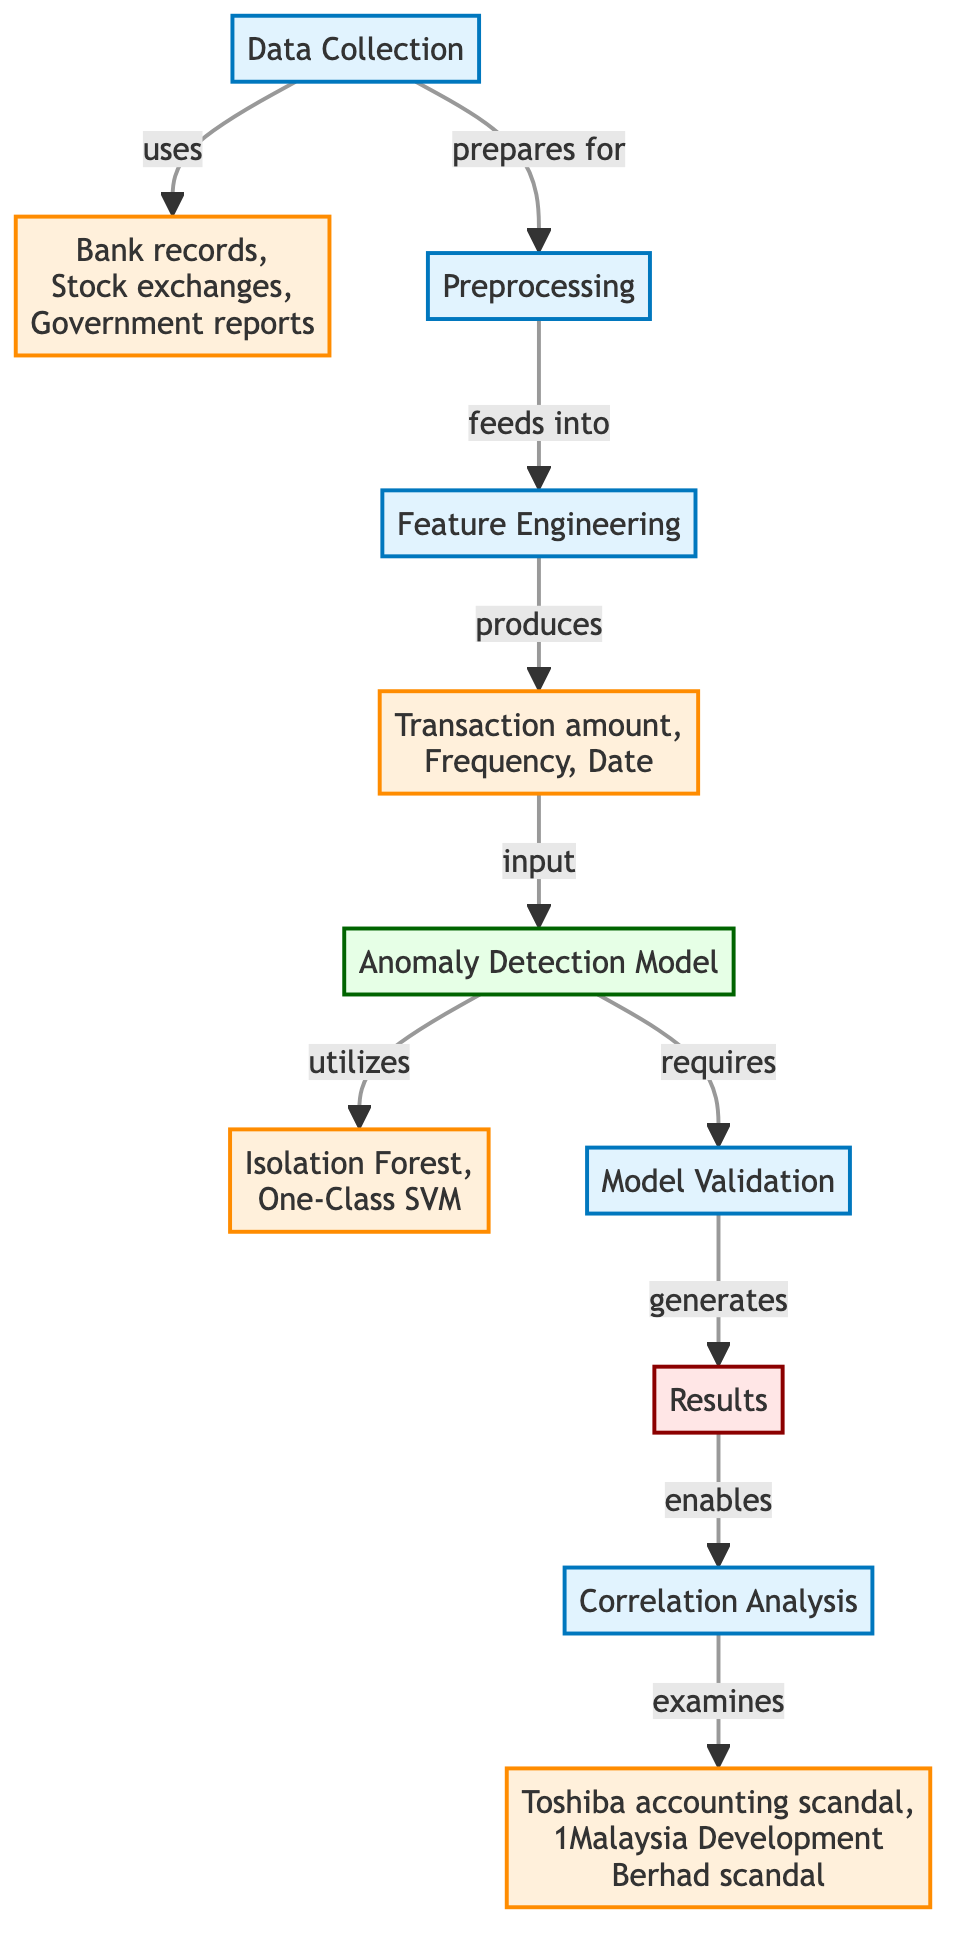What are the data sources listed in the diagram? The diagram explicitly names the data sources as "Bank records," "Stock exchanges," and "Government reports." These elements are located within the "Data Sources" node, directly associated with the "Data Collection" process.
Answer: Bank records, Stock exchanges, Government reports How many algorithms are utilized in the anomaly detection model? The diagram indicates that there are two algorithms listed within the "Algorithms" node: "Isolation Forest" and "One-Class SVM." Since these are explicitly mentioned, we count them to determine the total.
Answer: 2 What is the output of the model validation step? From the diagram, the "Model Validation" step feeds into the "Results" node. Therefore, the output of "Model Validation" is what is generated in the "Results" node, making the correlation clear.
Answer: Results What features are produced after feature engineering? The diagram shows that the feature engineering step produces features such as "Transaction amount," "Frequency," and "Date." These are directly related to the "Features" node in the flowchart.
Answer: Transaction amount, Frequency, Date Which historical case studies are examined during the correlation analysis? The "Correlation Analysis" node leads to an examination of specific historical case studies, namely the "Toshiba accounting scandal" and the "1Malaysia Development Berhad scandal," which are clearly defined in the diagram.
Answer: Toshiba accounting scandal, 1Malaysia Development Berhad scandal What is the purpose of the preprocessing step? The "Preprocessing" step is characterized in the diagram as a process that prepares data for the next stage, which is "Feature Engineering." It serves to organize and clean the collected data before extracting features.
Answer: Prepares for Feature Engineering What type of model is being utilized for anomaly detection in the diagram? The diagram specifies that an "Anomaly Detection Model" is being utilized in the process. This model is central to understanding the mechanism through which anomalies are detected in financial transactions.
Answer: Anomaly Detection Model How does the data flow from features to the anomaly detection model? According to the diagram, the "Features" produced in the feature engineering step serve as input to the "Anomaly Detection Model." This indicates a direct flow from one step to another in the analysis process.
Answer: Input to Anomaly Detection Model 